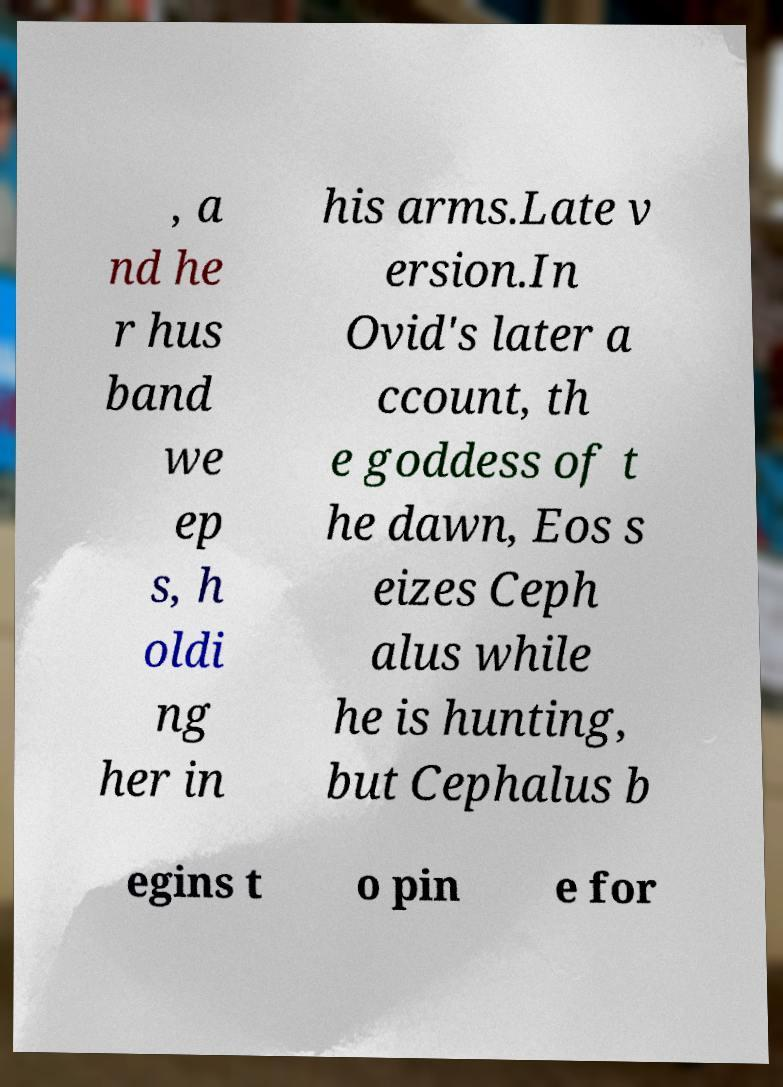I need the written content from this picture converted into text. Can you do that? , a nd he r hus band we ep s, h oldi ng her in his arms.Late v ersion.In Ovid's later a ccount, th e goddess of t he dawn, Eos s eizes Ceph alus while he is hunting, but Cephalus b egins t o pin e for 